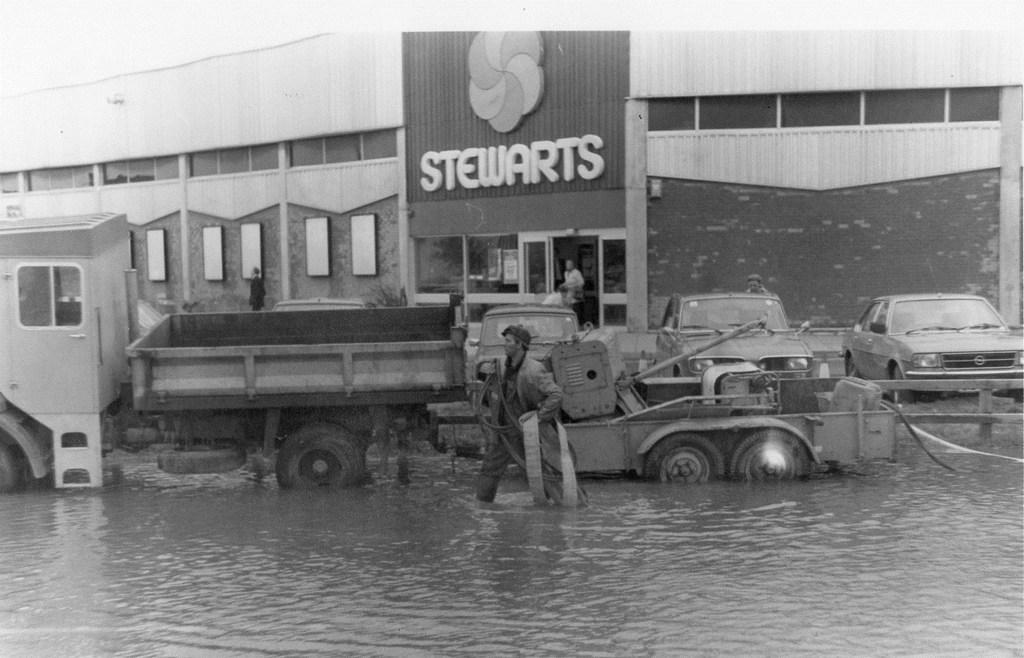What is the man in the image doing? The man is walking in the water. What else can be seen in the image besides the man? Vehicles, people, frames on the wall, a building, and other objects are visible in the image. Can you describe the vehicles in the image? Unfortunately, the facts provided do not give specific details about the vehicles. What is the purpose of the frames on the wall? The purpose of the frames on the wall is not mentioned in the provided facts. What type of banana can be seen growing out of the man's nose in the image? There is no banana growing out of the man's nose in the image; it is not present. 